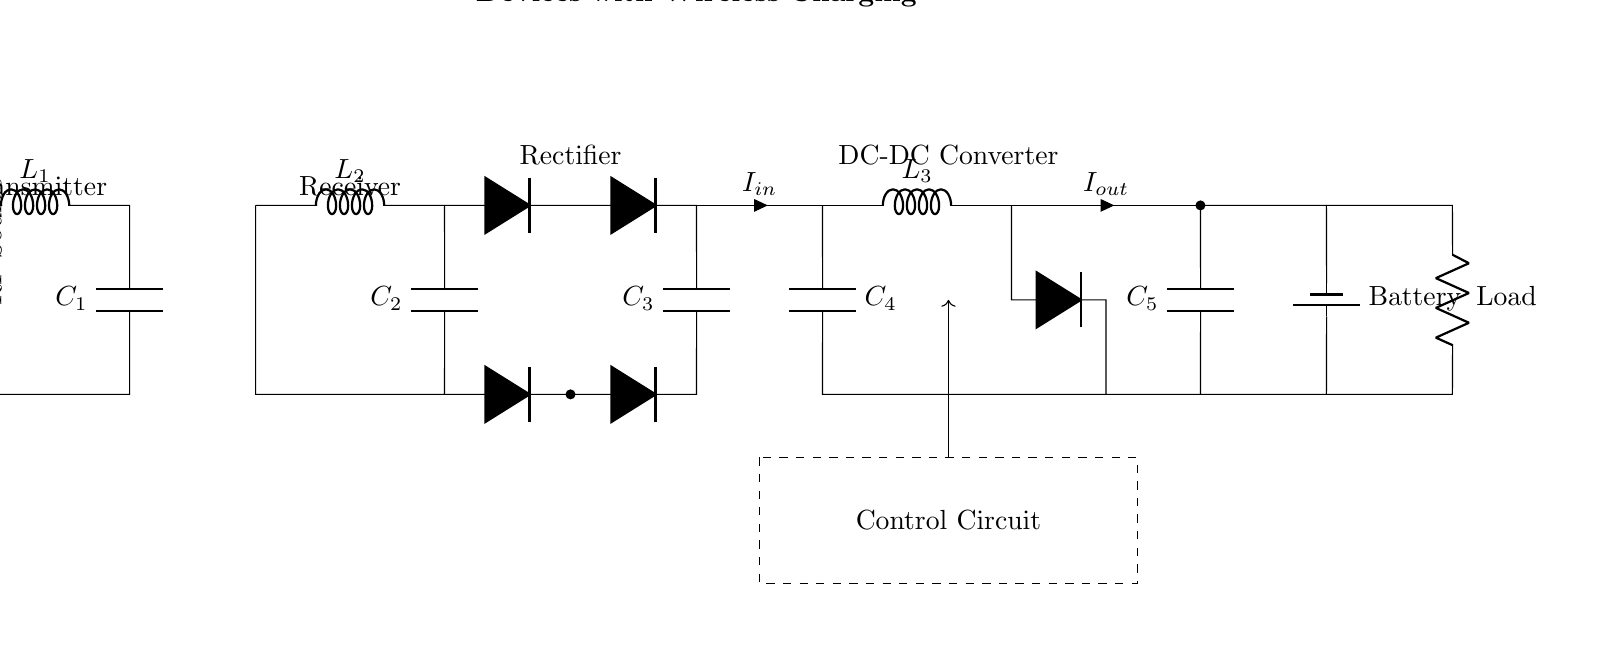What type of inductor is used in the wireless charging section? The inductor used in the wireless charging section is labeled as L1, which functions as a component in the resonant circuit for wireless energy transfer.
Answer: L1 What is the role of the capacitors in the circuit? The circuit contains several capacitors (C1, C2, C3, C4, and C5), which serve to store and smooth out electrical energy, filtering any fluctuations in the voltage and ensuring stable power delivery to the load.
Answer: Smoothing Which components are part of the rectifier? The rectifier consists of four diodes (indicated by D*) and one capacitor (C3), which work together to convert alternating current into direct current for the DC-DC converter.
Answer: Four diodes and one capacitor How many inductors are used in the DC-DC converter section? In the DC-DC converter section, there is one inductor labeled L3, which is responsible for regulating the output current and voltage levels to match the needs of the load.
Answer: One What is the current input denoted as in the circuit? The input current is denoted as I_in, which indicates the flow of current into the DC-DC converter from the rectifier section for power management.
Answer: I_in What is the purpose of the control circuit? The control circuit is designed to manage the system's operation, ensuring proper power distribution and regulating the charging process to optimize battery longevity and efficiency, as depicted by the dashed rectangle surrounding it.
Answer: Power management 